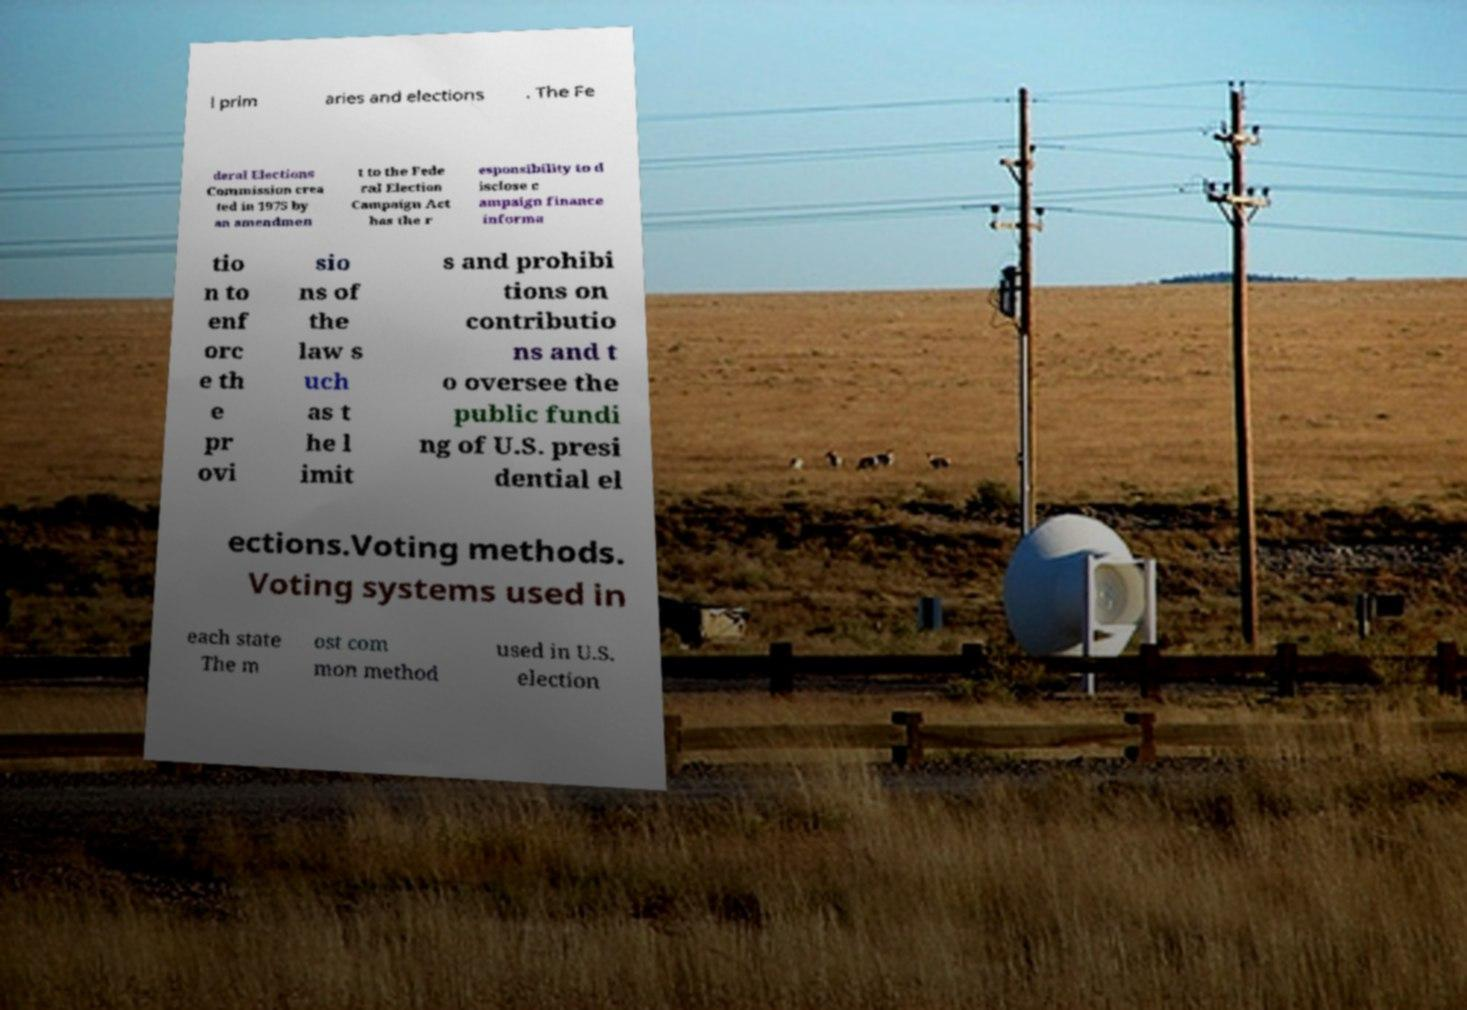For documentation purposes, I need the text within this image transcribed. Could you provide that? l prim aries and elections . The Fe deral Elections Commission crea ted in 1975 by an amendmen t to the Fede ral Election Campaign Act has the r esponsibility to d isclose c ampaign finance informa tio n to enf orc e th e pr ovi sio ns of the law s uch as t he l imit s and prohibi tions on contributio ns and t o oversee the public fundi ng of U.S. presi dential el ections.Voting methods. Voting systems used in each state The m ost com mon method used in U.S. election 